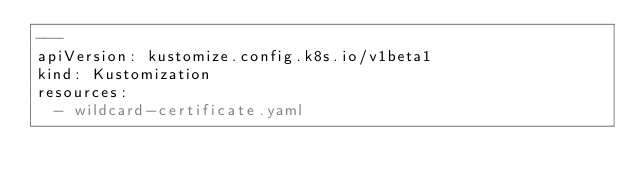Convert code to text. <code><loc_0><loc_0><loc_500><loc_500><_YAML_>---
apiVersion: kustomize.config.k8s.io/v1beta1
kind: Kustomization
resources:
  - wildcard-certificate.yaml
</code> 